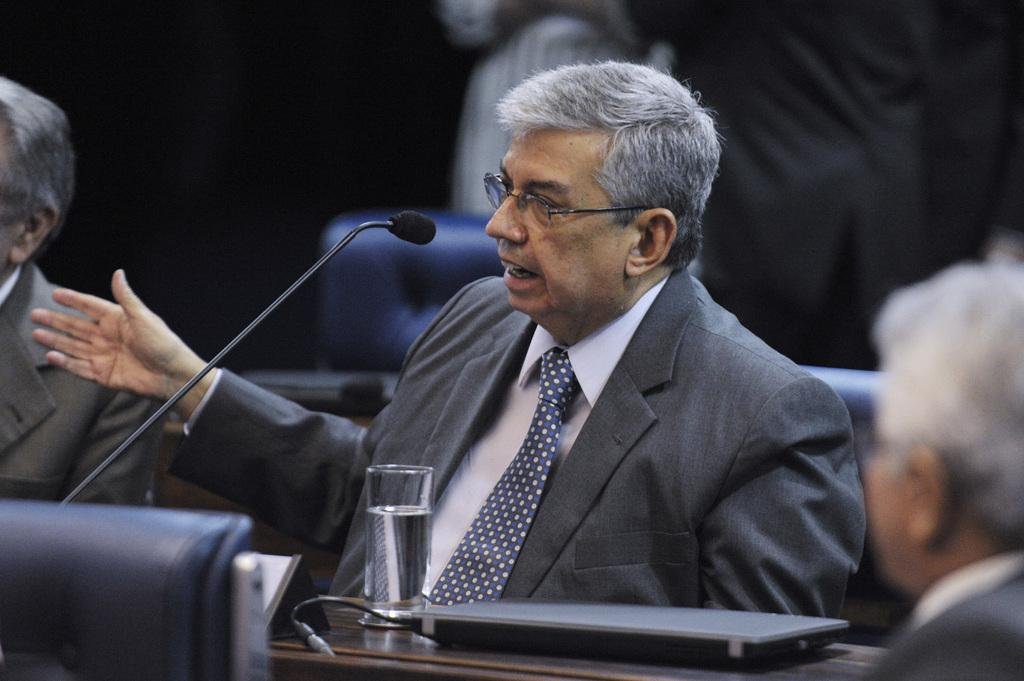Who is present in the image? There is a person in the image. What is the person wearing? The person is wearing a coat. What is the person doing in the image? The person is sitting. What object is the person holding in the image? There is a microphone in the image. What type of electronic device can be seen in the image? There is an electronic device in the image. What is on the table in the image? There is a water glass on a table in the image. How many spiders are crawling on the person in the image? There are no spiders present in the image. What type of hook is the person using to record history in the image? There is no hook or reference to recording history in the image. 